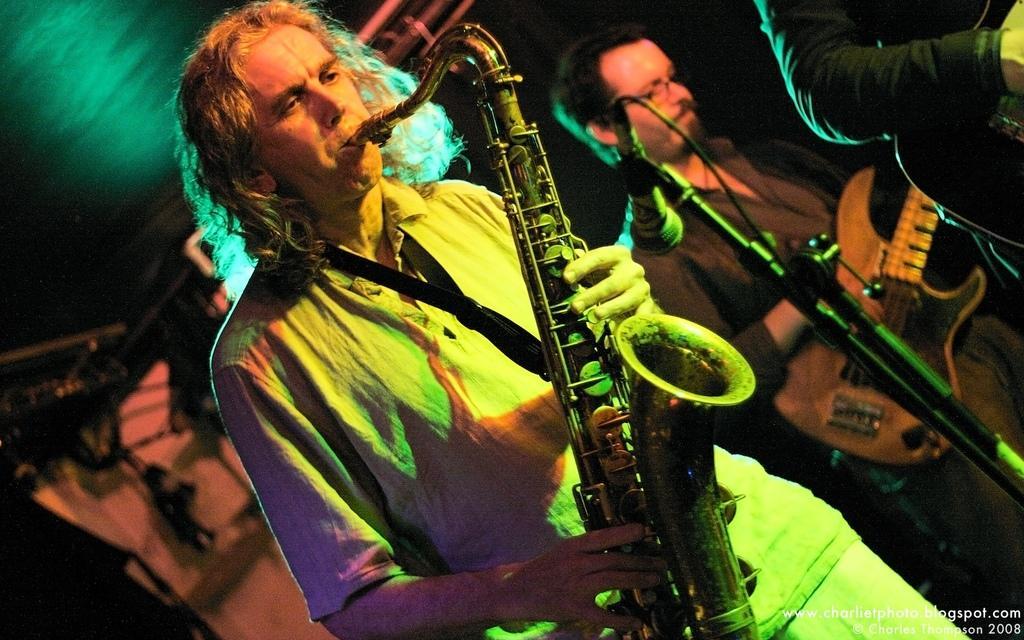Describe this image in one or two sentences. On the bottom right, there is a watermark. On the right side, there are three persons playing musical instruments on a stage. Beside them, there is a mic attached to a stand. In the background, there is a roof and other objects. And the background is dark in color. 